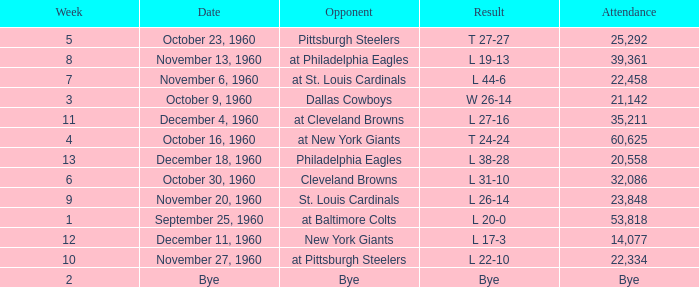Which Week had a Date of december 4, 1960? 11.0. 